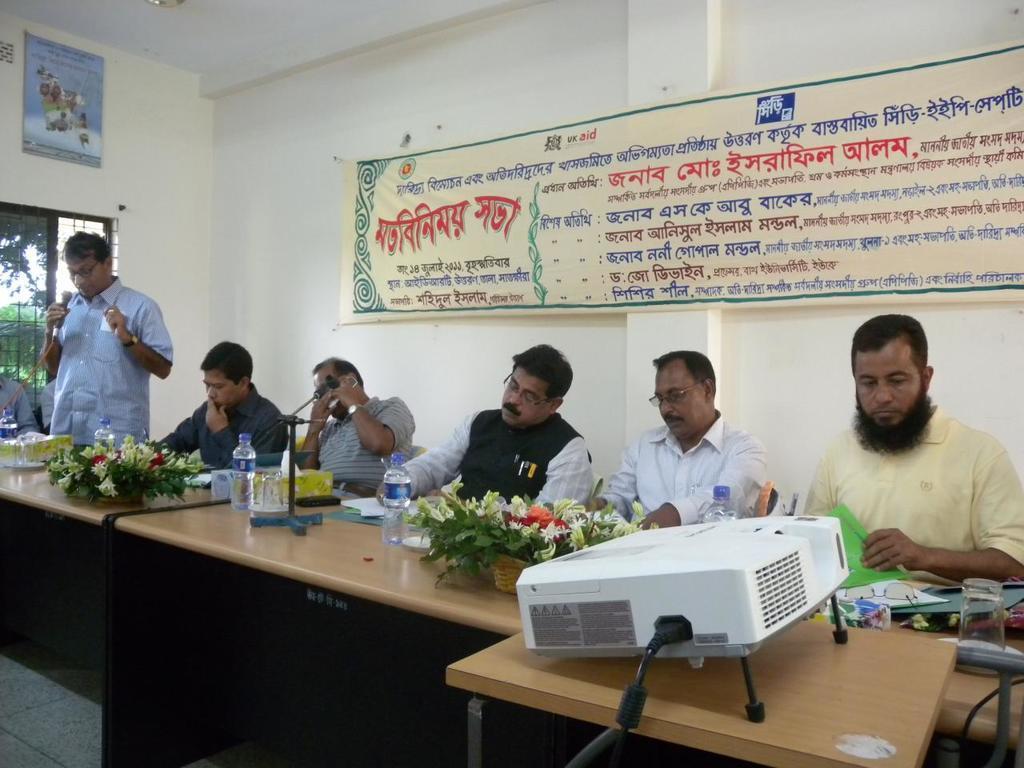In one or two sentences, can you explain what this image depicts? This image consists of group of people sitting and working, to the left corner there is a person standing and holding a microphone, in front there is a projector, behind there is poster with text on it which is attached to the wall. 